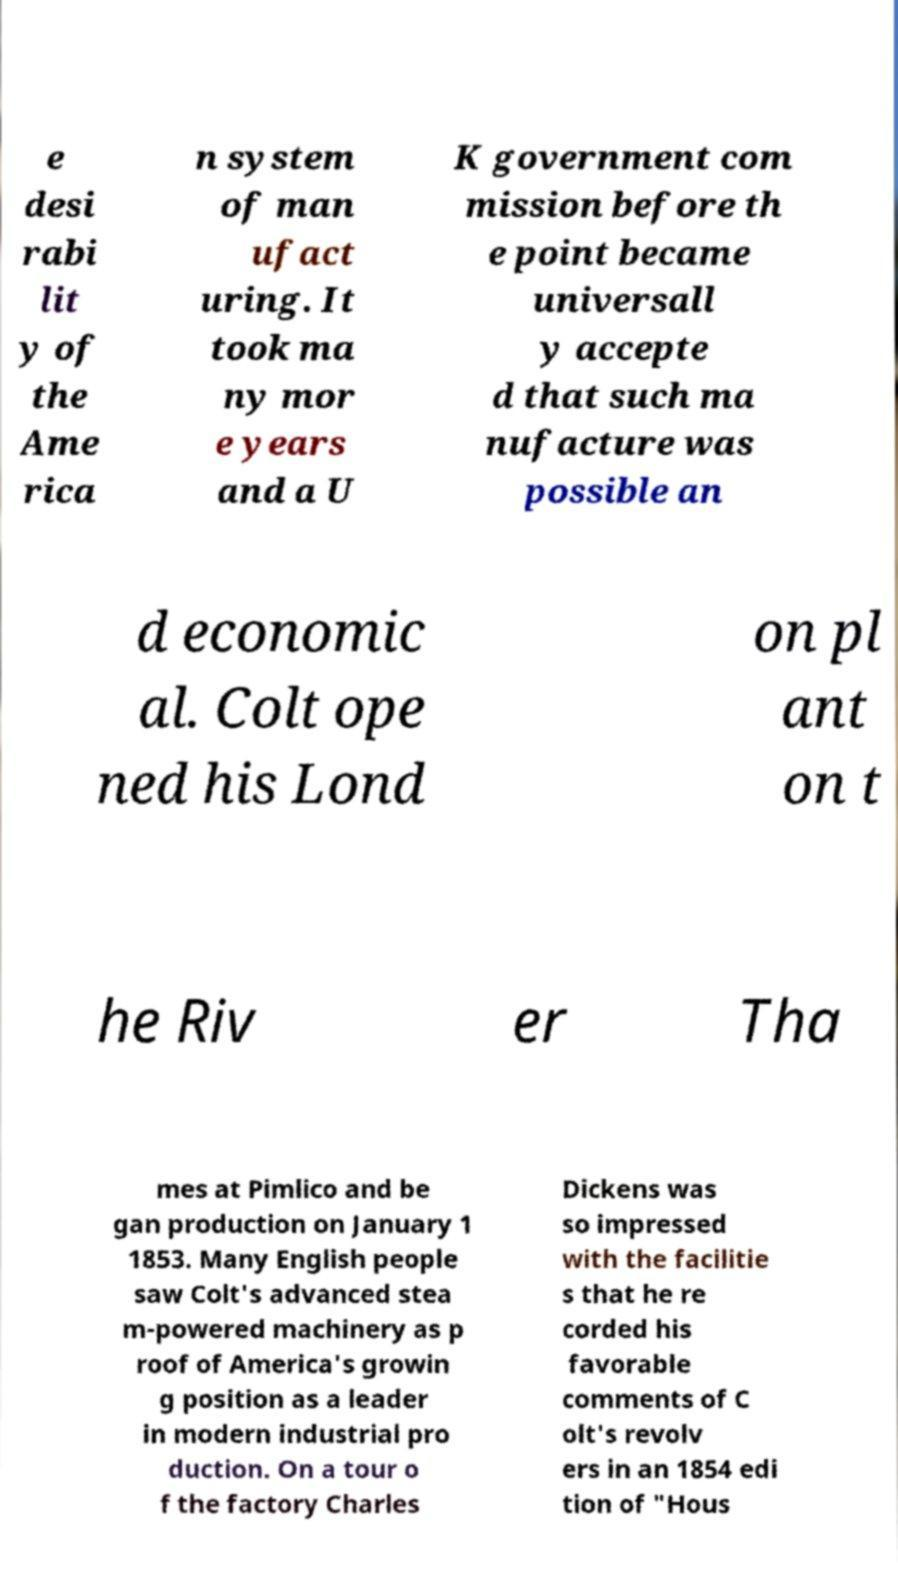Please identify and transcribe the text found in this image. e desi rabi lit y of the Ame rica n system of man ufact uring. It took ma ny mor e years and a U K government com mission before th e point became universall y accepte d that such ma nufacture was possible an d economic al. Colt ope ned his Lond on pl ant on t he Riv er Tha mes at Pimlico and be gan production on January 1 1853. Many English people saw Colt's advanced stea m-powered machinery as p roof of America's growin g position as a leader in modern industrial pro duction. On a tour o f the factory Charles Dickens was so impressed with the facilitie s that he re corded his favorable comments of C olt's revolv ers in an 1854 edi tion of "Hous 